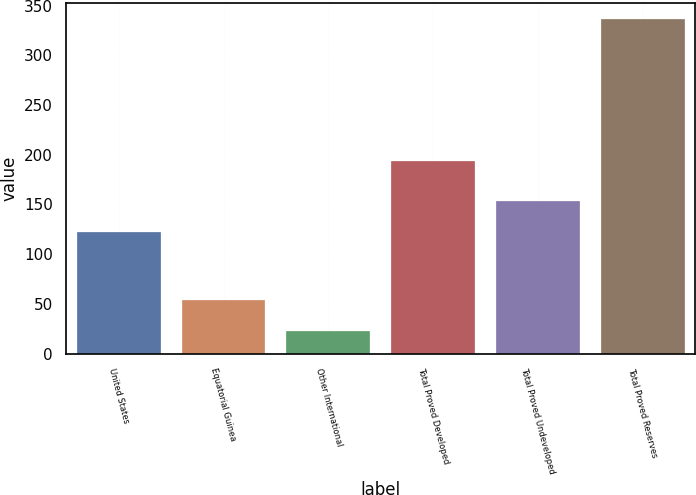Convert chart to OTSL. <chart><loc_0><loc_0><loc_500><loc_500><bar_chart><fcel>United States<fcel>Equatorial Guinea<fcel>Other International<fcel>Total Proved Developed<fcel>Total Proved Undeveloped<fcel>Total Proved Reserves<nl><fcel>122<fcel>54.3<fcel>23<fcel>194<fcel>153.3<fcel>336<nl></chart> 